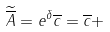Convert formula to latex. <formula><loc_0><loc_0><loc_500><loc_500>\widetilde { \overline { A } } = e ^ { \delta } \overline { c } = \overline { c } +</formula> 